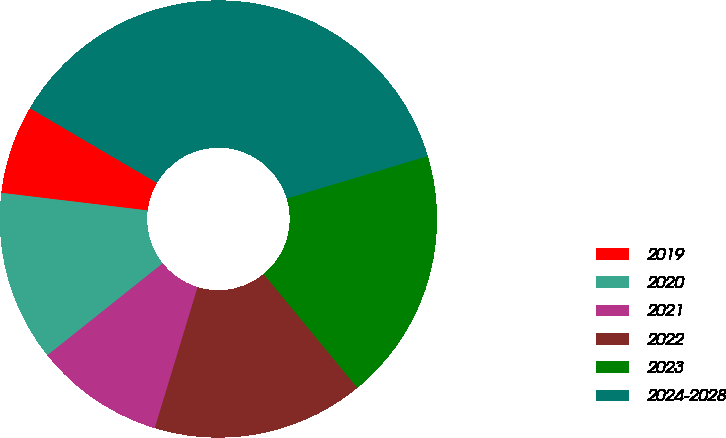Convert chart. <chart><loc_0><loc_0><loc_500><loc_500><pie_chart><fcel>2019<fcel>2020<fcel>2021<fcel>2022<fcel>2023<fcel>2024-2028<nl><fcel>6.55%<fcel>12.62%<fcel>9.59%<fcel>15.66%<fcel>18.69%<fcel>36.9%<nl></chart> 